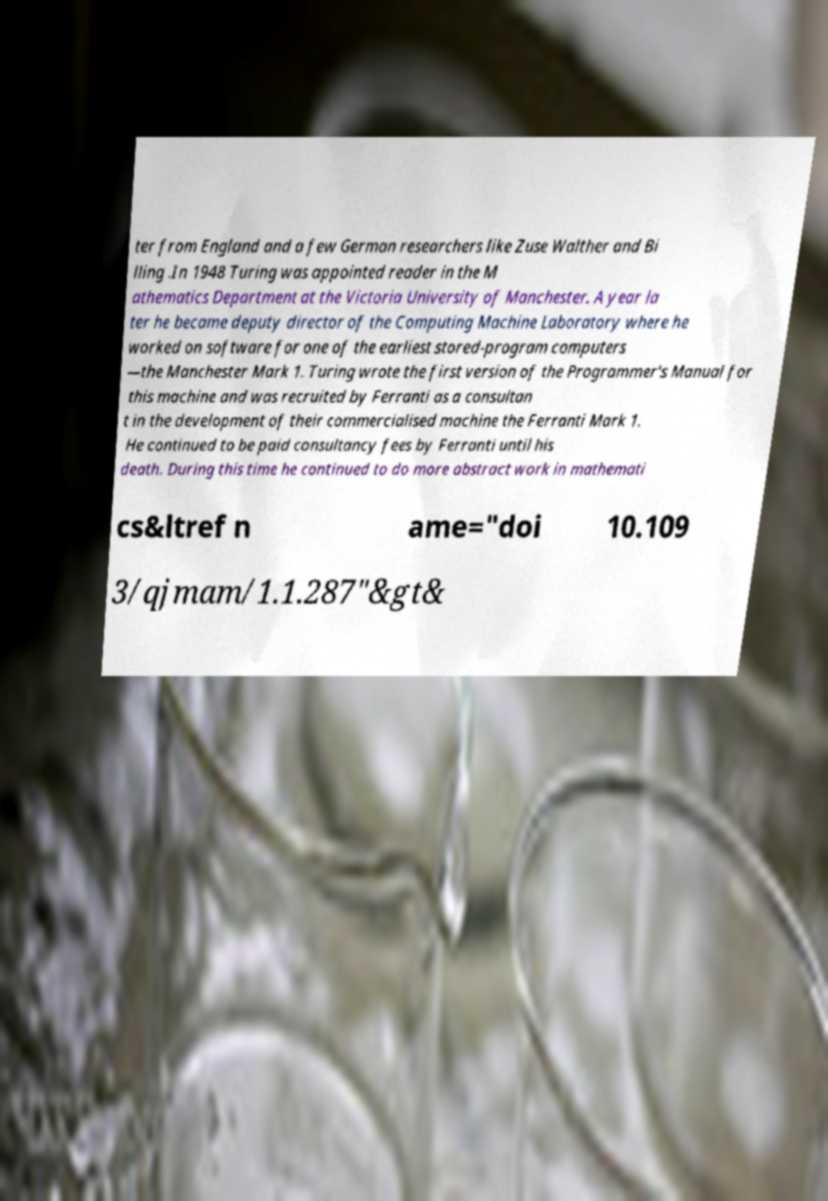There's text embedded in this image that I need extracted. Can you transcribe it verbatim? ter from England and a few German researchers like Zuse Walther and Bi lling .In 1948 Turing was appointed reader in the M athematics Department at the Victoria University of Manchester. A year la ter he became deputy director of the Computing Machine Laboratory where he worked on software for one of the earliest stored-program computers —the Manchester Mark 1. Turing wrote the first version of the Programmer's Manual for this machine and was recruited by Ferranti as a consultan t in the development of their commercialised machine the Ferranti Mark 1. He continued to be paid consultancy fees by Ferranti until his death. During this time he continued to do more abstract work in mathemati cs&ltref n ame="doi 10.109 3/qjmam/1.1.287"&gt& 